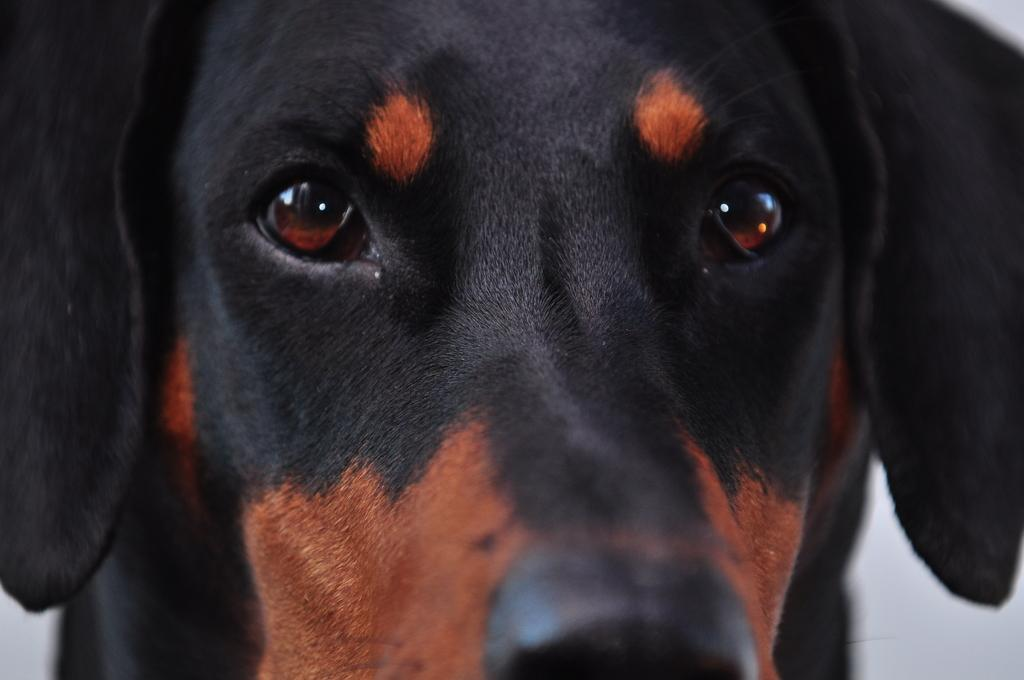What animal is present in the picture? There is a dog in the picture. What is the state of the dog's eyes? The dog has its eyes opened. What type of badge is the dog wearing in the picture? There is no badge present on the dog in the image. What kind of rat can be seen interacting with the dog in the picture? There is no rat present in the image; it features a dog with its eyes opened. 